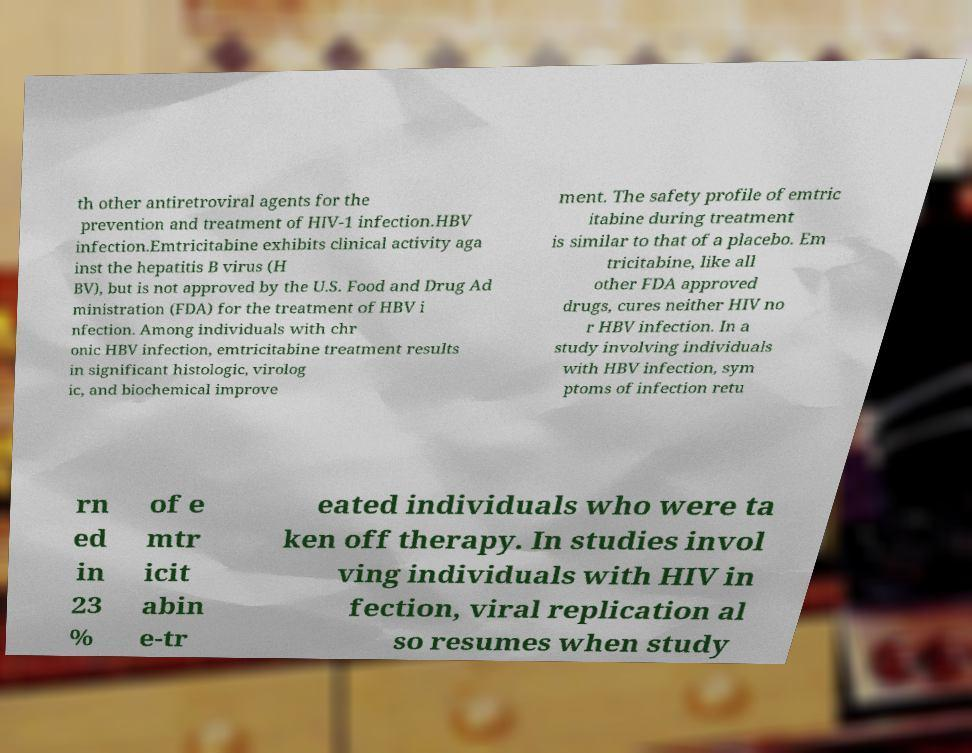Please read and relay the text visible in this image. What does it say? th other antiretroviral agents for the prevention and treatment of HIV-1 infection.HBV infection.Emtricitabine exhibits clinical activity aga inst the hepatitis B virus (H BV), but is not approved by the U.S. Food and Drug Ad ministration (FDA) for the treatment of HBV i nfection. Among individuals with chr onic HBV infection, emtricitabine treatment results in significant histologic, virolog ic, and biochemical improve ment. The safety profile of emtric itabine during treatment is similar to that of a placebo. Em tricitabine, like all other FDA approved drugs, cures neither HIV no r HBV infection. In a study involving individuals with HBV infection, sym ptoms of infection retu rn ed in 23 % of e mtr icit abin e-tr eated individuals who were ta ken off therapy. In studies invol ving individuals with HIV in fection, viral replication al so resumes when study 